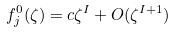<formula> <loc_0><loc_0><loc_500><loc_500>f _ { j } ^ { 0 } ( \zeta ) = c \zeta ^ { I } + O ( \zeta ^ { I + 1 } )</formula> 